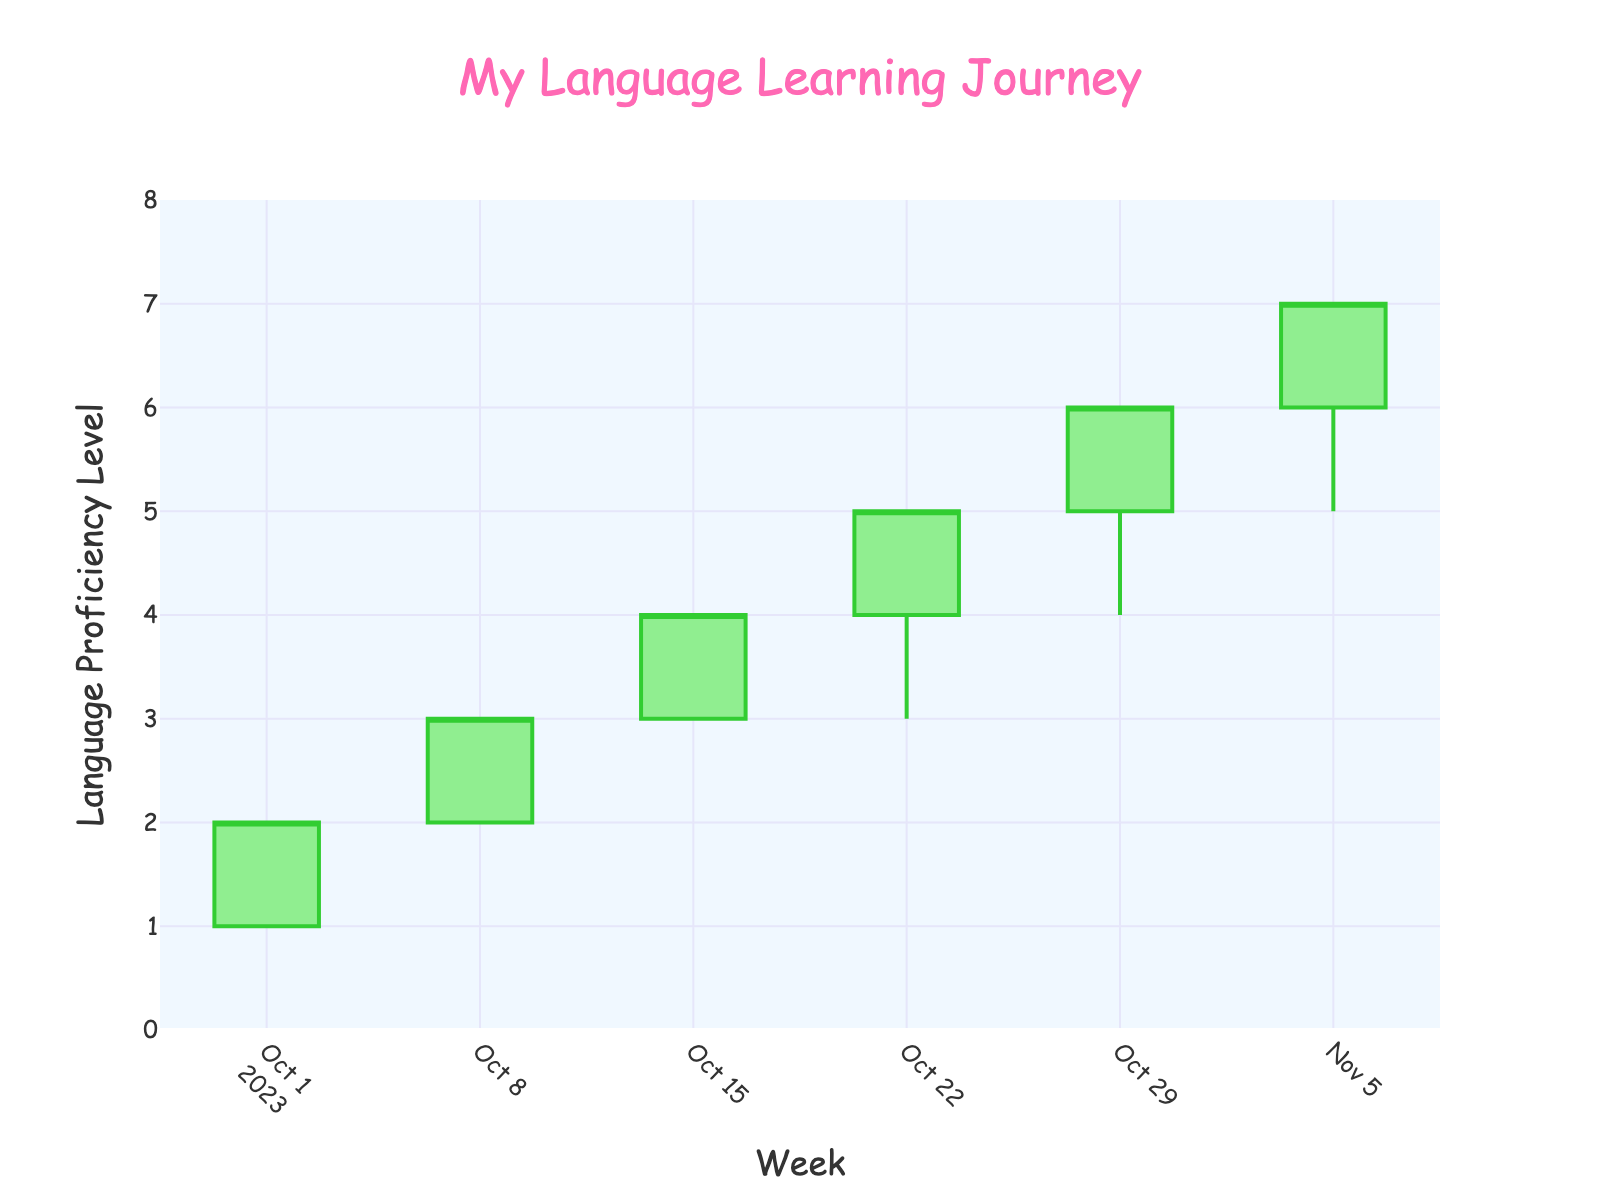What is the title of the figure? The title of the figure is displayed at the top of the chart in a larger font size and different color compared to other text elements. It reads: "My Language Learning Journey".
Answer: My Language Learning Journey What color are the increasing candlesticks? The increasing candlesticks are a specific color indicating growth or improvement. They are colored in green tones.
Answer: Green How many data points are shown in the plot? By counting the unique dates along the x-axis, we can determine the number of data points. There are six distinct dates, indicating six data points.
Answer: Six On which date did the proficiency level reach the highest closing value? By examining the highest 'Close' values on the y-axis and corresponding dates on the x-axis, the highest value reaches '7' on 2023-11-05.
Answer: 2023-11-05 Between which two consecutive weeks was the biggest increase in proficiency level observed? We need to compute the difference between closing values of consecutive weeks to identify the largest increase. From 2023-10-01 to 2023-10-08, the increase is 1; from 2023-10-08 to 2023-10-15, the increase is 1; from 2023-10-15 to 2023-10-22, the increase is 1; from 2023-10-22 to 2023-10-29, the increase is 1; and from 2023-10-29 to 2023-11-05, the increase is 1. Thus, they all have the same increase of 1.
Answer: 2023-10-01 to 2023-10-08 How many candlesticks have their 'Low' value at '3'? We need to count the candlestick entries where the 'Low' value intersected with level 3. There are two such entries on 2023-10-22 and 2023-10-15.
Answer: Two Which value does the y-axis start from and extend to? Observing the y-axis range, it starts from '0' and extends to '8'. This range helps contextualize proficiency levels.
Answer: 0 to 8 How does the proficiency level change from 2023-10-01 to 2023-10-29? By looking at the closing values on these dates, the values are 2, 3, 4, 5, and 6 respectively, indicating a consistent increase each week.
Answer: Increasing steadily What is the difference between the highest and lowest opening proficiency levels? Compare the highest opening value on 2023-11-05, which is '6', with the lowest opening value on 2023-10-01, which is '1'. The difference is calculated as 6 - 1.
Answer: 5 Describe the color scheme used for the plot background. The plot background is described by its color which is light and visually distinctive from the candlesticks. It is light blue.
Answer: Light blue 